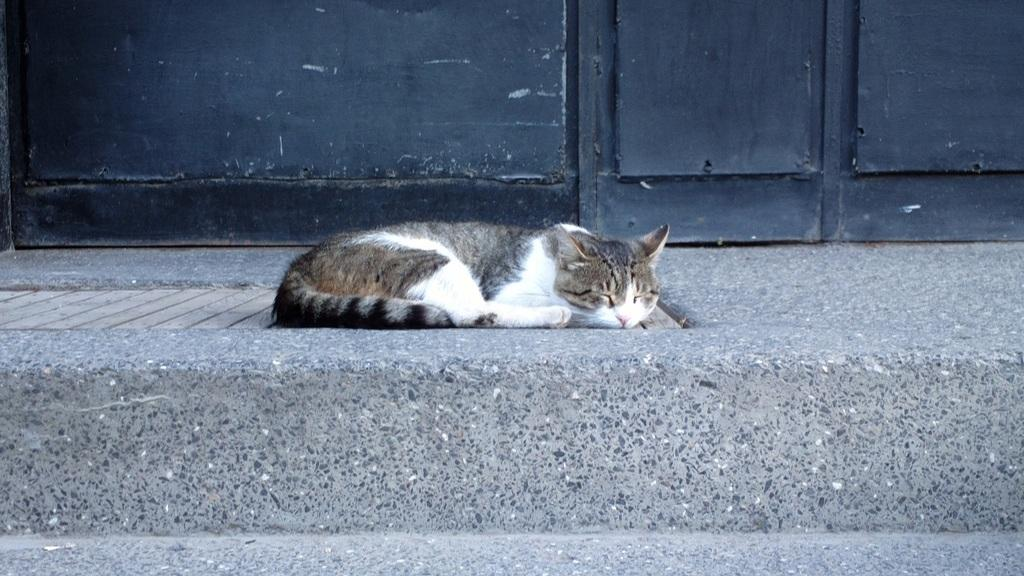What type of animal is present in the image? There is a cat in the image. What is the cat doing in the image? The cat is sleeping. On what surface is the cat lying? The cat is lying on a wooden floor. What can be seen in the background of the image? There is a wall in the background of the image. What type of rhythm can be heard coming from the cat in the image? There is no sound or rhythm associated with the cat in the image; it is simply sleeping on a wooden floor. 